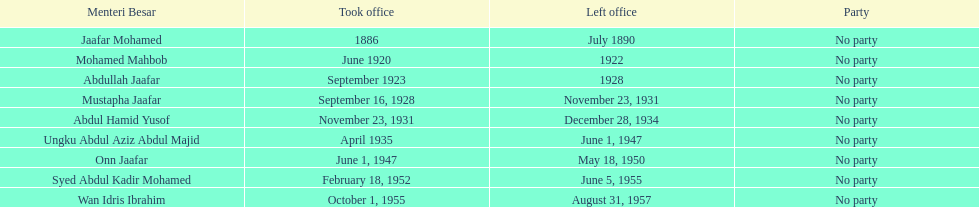How long did ungku abdul aziz abdul majid serve? 12 years. 